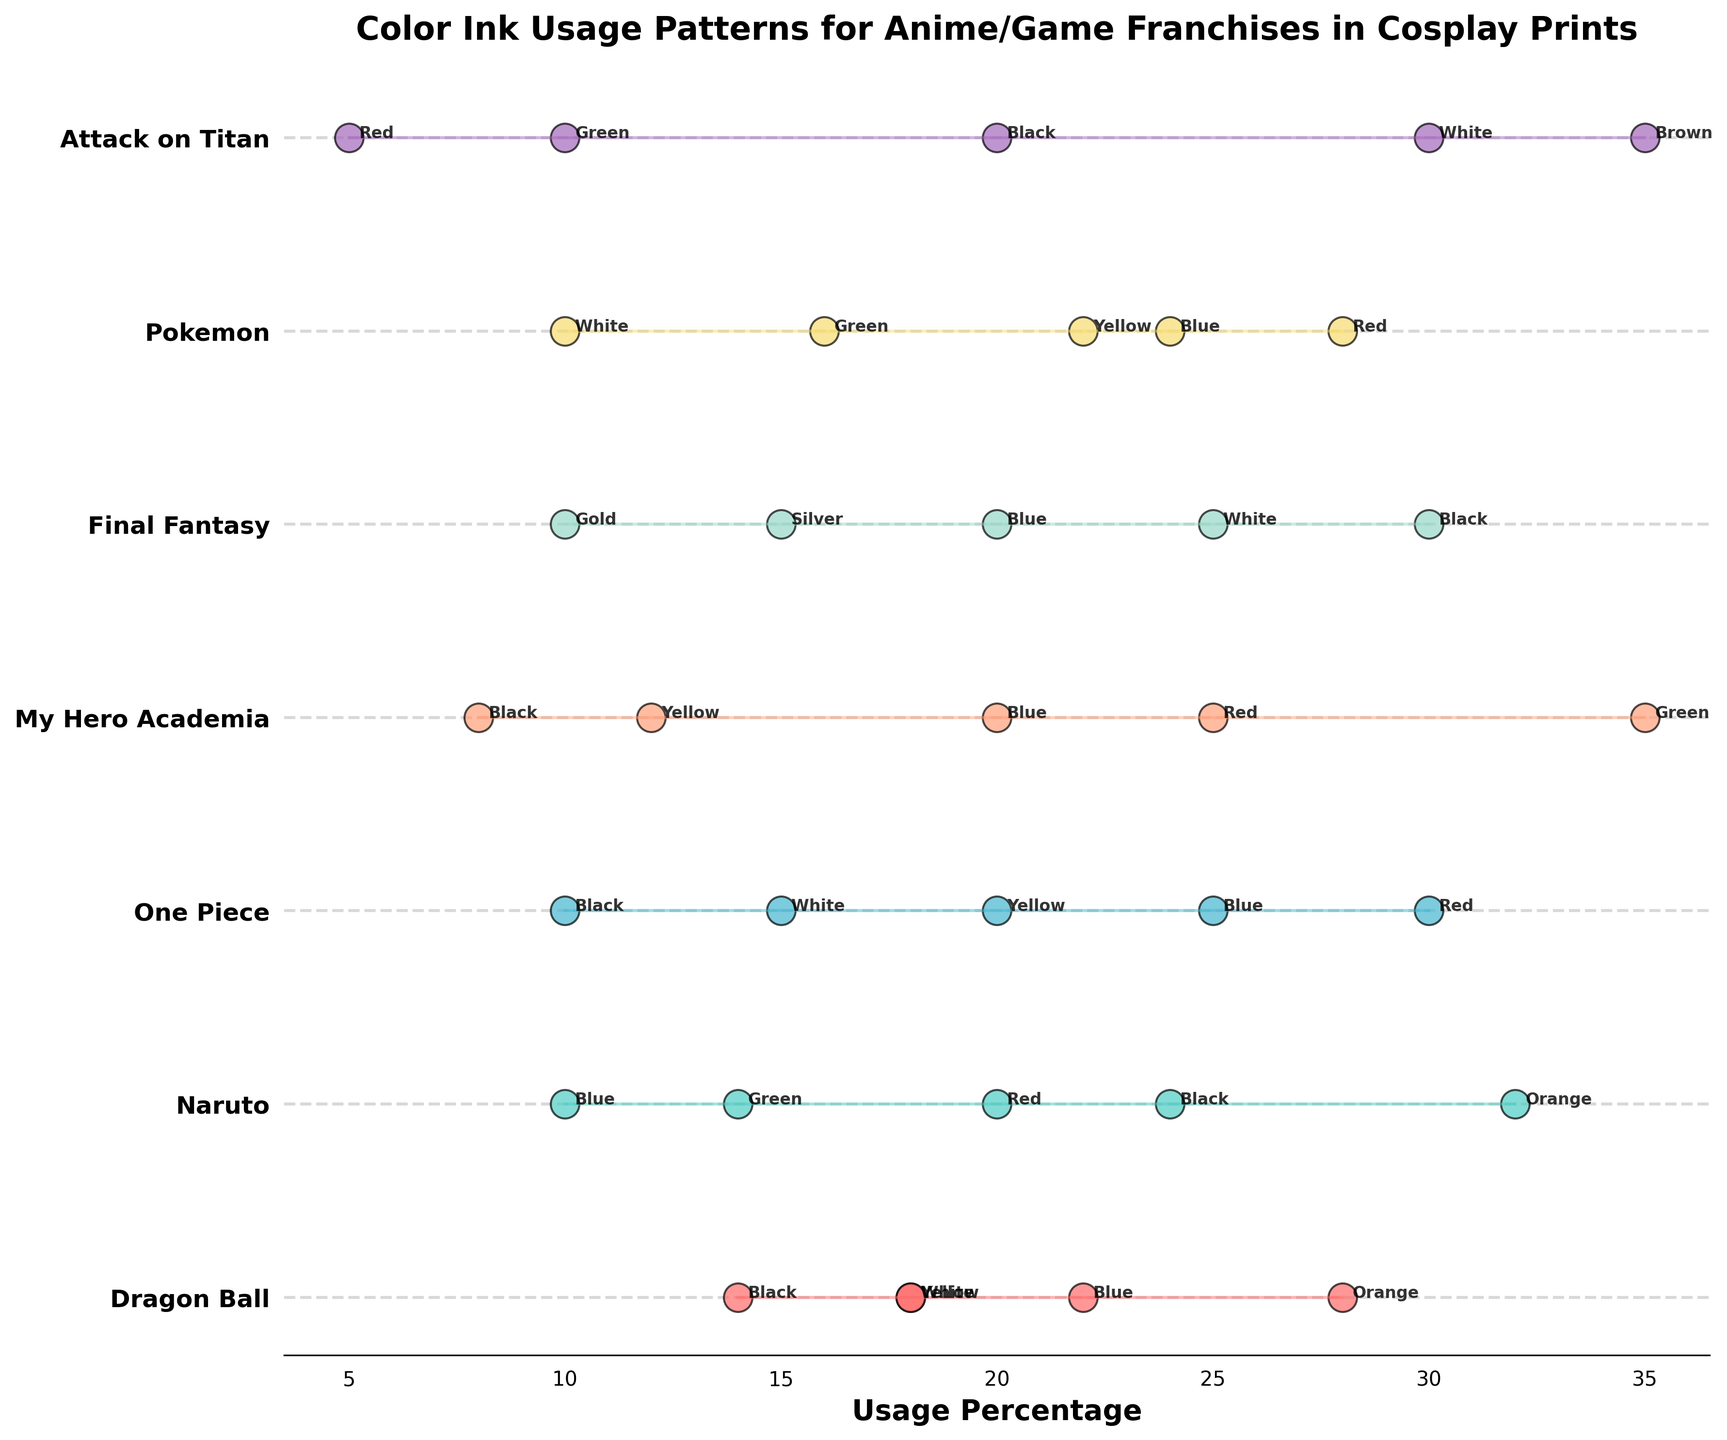What is the title of the figure? Look at the top of the figure where the title is usually located. It is given in large, bold font.
Answer: Color Ink Usage Patterns for Anime/Game Franchises in Cosplay Prints Which franchise uses the most varied colors in their prints? Compare the number of colors used by each franchise. The franchise with the most unique colors has the most varied color usage.
Answer: Naruto What is the highest usage percentage of any single color, and for which franchise? Identify the franchise-color pair with the highest percentage value. This is the peak of the usage percentage in the plot.
Answer: Attack on Titan, Brown, 35% Which franchise has the highest average usage percentage of black ink? Calculate the average usage percentage of black ink for each franchise and compare them.
Answer: Final Fantasy Are there any franchises that do not use red color ink? Check the data points for each franchise to see if red color is missing from any of them.
Answer: My Hero Academia, Attack on Titan Which two colors have the closest usage percentages within the Pokemon franchise? Examine the usage percentages for the colors under Pokemon and find the two values with the smallest difference.
Answer: White and Green Between Dragon Ball and One Piece, which franchise uses blue ink more? Compare the blue ink usage percentages between Dragon Ball and One Piece.
Answer: One Piece Which franchise has the least usage percentage for its top color? Identify the top color for each franchise and then compare the percentage values to find the lowest.
Answer: My Hero Academia How many franchises have green ink usage percentages above 10%? Count the franchises where the green ink usage percentage is greater than 10%.
Answer: 3 What is the usage percentage difference of yellow ink between Pokemon and Dragon Ball? Find the usage percentages of yellow ink for Pokemon and Dragon Ball, then calculate their difference.
Answer: 4% 